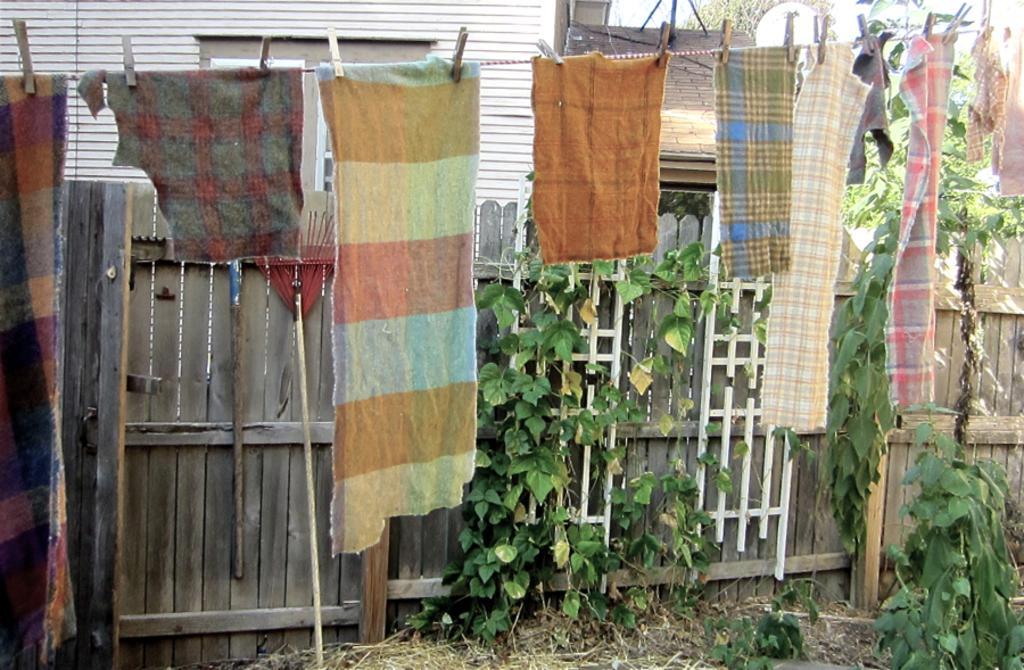Can you describe this image briefly? There is a house in the image, different clothes are hung on a rope and clipped to it and plants and creepers are there in the image. 